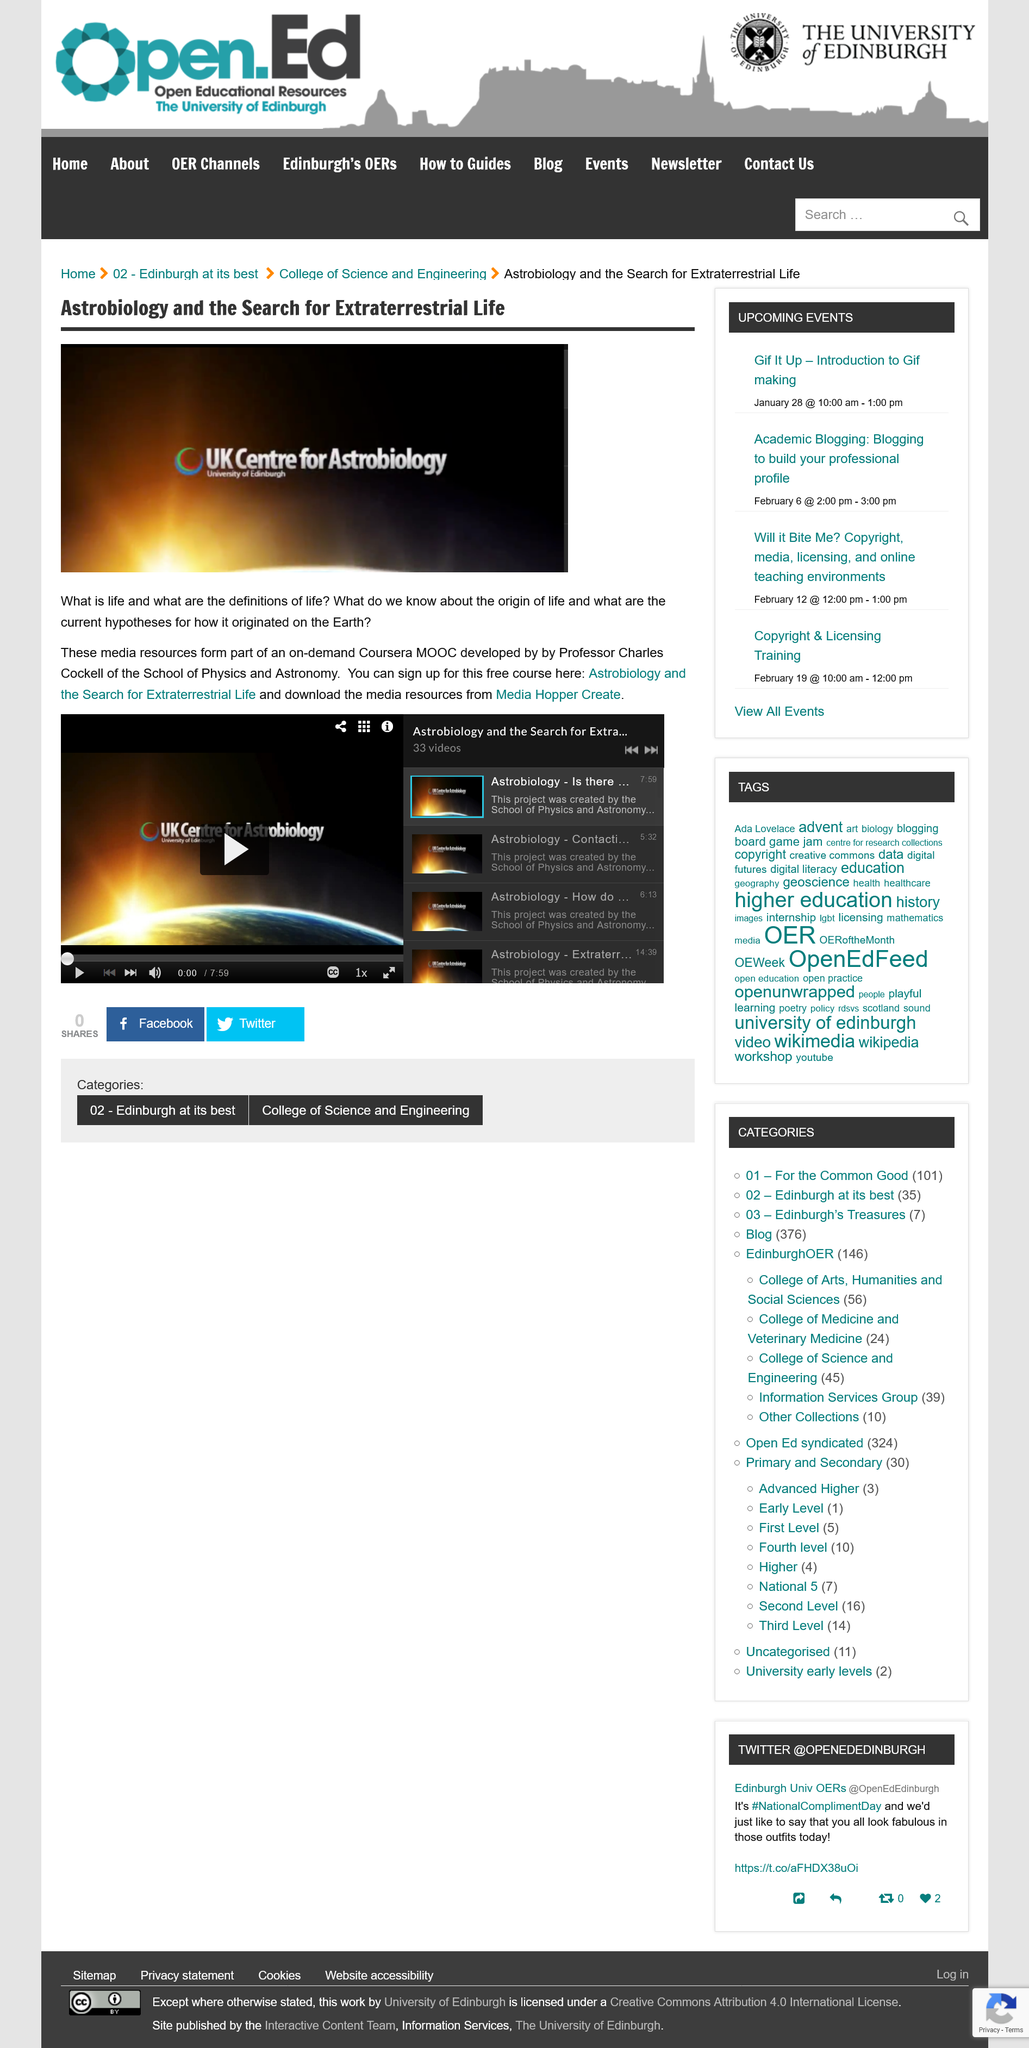Give some essential details in this illustration. The Coursera MOOC "Astrobiology and the Search for Extraterrestrial Life" was developed by Professor Charles Cockell. There are 33 videos available for the topic of "Astrobiology and the Search for Extraterrestrial Life. The media resources can be accessed and downloaded from Media Hopper Create. 